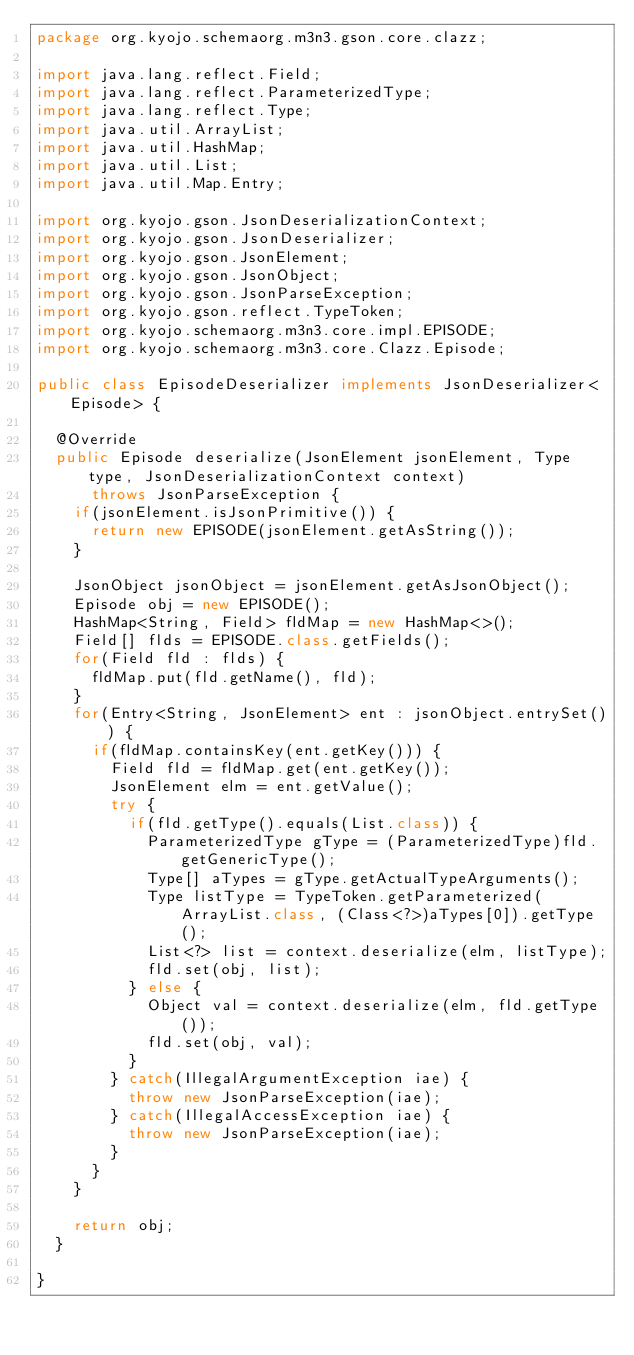Convert code to text. <code><loc_0><loc_0><loc_500><loc_500><_Java_>package org.kyojo.schemaorg.m3n3.gson.core.clazz;

import java.lang.reflect.Field;
import java.lang.reflect.ParameterizedType;
import java.lang.reflect.Type;
import java.util.ArrayList;
import java.util.HashMap;
import java.util.List;
import java.util.Map.Entry;

import org.kyojo.gson.JsonDeserializationContext;
import org.kyojo.gson.JsonDeserializer;
import org.kyojo.gson.JsonElement;
import org.kyojo.gson.JsonObject;
import org.kyojo.gson.JsonParseException;
import org.kyojo.gson.reflect.TypeToken;
import org.kyojo.schemaorg.m3n3.core.impl.EPISODE;
import org.kyojo.schemaorg.m3n3.core.Clazz.Episode;

public class EpisodeDeserializer implements JsonDeserializer<Episode> {

	@Override
	public Episode deserialize(JsonElement jsonElement, Type type, JsonDeserializationContext context)
			throws JsonParseException {
		if(jsonElement.isJsonPrimitive()) {
			return new EPISODE(jsonElement.getAsString());
		}

		JsonObject jsonObject = jsonElement.getAsJsonObject();
		Episode obj = new EPISODE();
		HashMap<String, Field> fldMap = new HashMap<>();
		Field[] flds = EPISODE.class.getFields();
		for(Field fld : flds) {
			fldMap.put(fld.getName(), fld);
		}
		for(Entry<String, JsonElement> ent : jsonObject.entrySet()) {
			if(fldMap.containsKey(ent.getKey())) {
				Field fld = fldMap.get(ent.getKey());
				JsonElement elm = ent.getValue();
				try {
					if(fld.getType().equals(List.class)) {
						ParameterizedType gType = (ParameterizedType)fld.getGenericType();
						Type[] aTypes = gType.getActualTypeArguments();
						Type listType = TypeToken.getParameterized(ArrayList.class, (Class<?>)aTypes[0]).getType();
						List<?> list = context.deserialize(elm, listType);
						fld.set(obj, list);
					} else {
						Object val = context.deserialize(elm, fld.getType());
						fld.set(obj, val);
					}
				} catch(IllegalArgumentException iae) {
					throw new JsonParseException(iae);
				} catch(IllegalAccessException iae) {
					throw new JsonParseException(iae);
				}
			}
		}

		return obj;
	}

}
</code> 